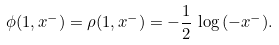Convert formula to latex. <formula><loc_0><loc_0><loc_500><loc_500>\phi ( 1 , x ^ { - } ) = \rho ( 1 , x ^ { - } ) = - { \frac { 1 } { 2 } } \, \log \, ( - x ^ { - } ) .</formula> 